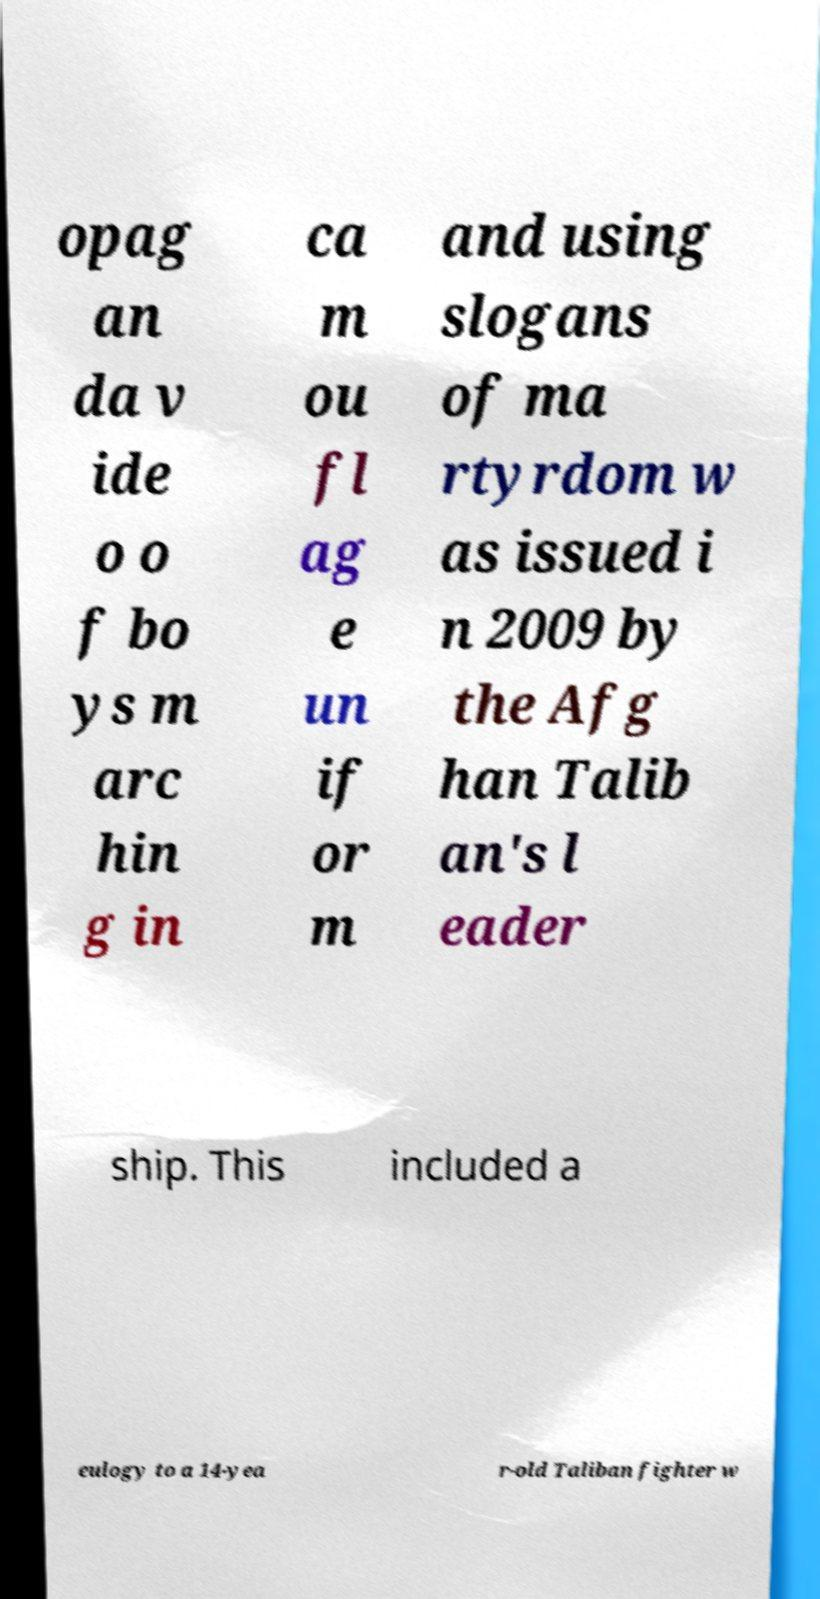What messages or text are displayed in this image? I need them in a readable, typed format. opag an da v ide o o f bo ys m arc hin g in ca m ou fl ag e un if or m and using slogans of ma rtyrdom w as issued i n 2009 by the Afg han Talib an's l eader ship. This included a eulogy to a 14-yea r-old Taliban fighter w 